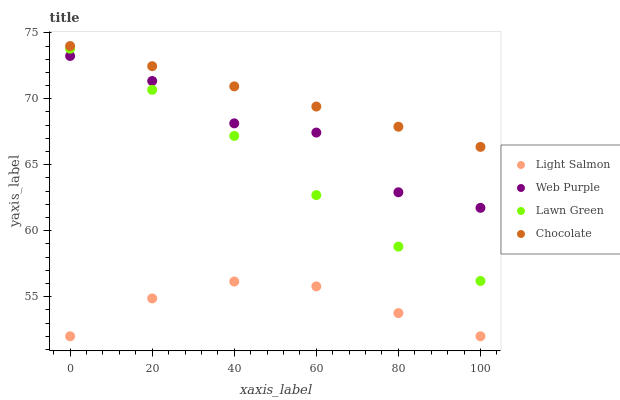Does Light Salmon have the minimum area under the curve?
Answer yes or no. Yes. Does Chocolate have the maximum area under the curve?
Answer yes or no. Yes. Does Web Purple have the minimum area under the curve?
Answer yes or no. No. Does Web Purple have the maximum area under the curve?
Answer yes or no. No. Is Chocolate the smoothest?
Answer yes or no. Yes. Is Web Purple the roughest?
Answer yes or no. Yes. Is Light Salmon the smoothest?
Answer yes or no. No. Is Light Salmon the roughest?
Answer yes or no. No. Does Light Salmon have the lowest value?
Answer yes or no. Yes. Does Web Purple have the lowest value?
Answer yes or no. No. Does Chocolate have the highest value?
Answer yes or no. Yes. Does Web Purple have the highest value?
Answer yes or no. No. Is Light Salmon less than Chocolate?
Answer yes or no. Yes. Is Chocolate greater than Lawn Green?
Answer yes or no. Yes. Does Lawn Green intersect Web Purple?
Answer yes or no. Yes. Is Lawn Green less than Web Purple?
Answer yes or no. No. Is Lawn Green greater than Web Purple?
Answer yes or no. No. Does Light Salmon intersect Chocolate?
Answer yes or no. No. 